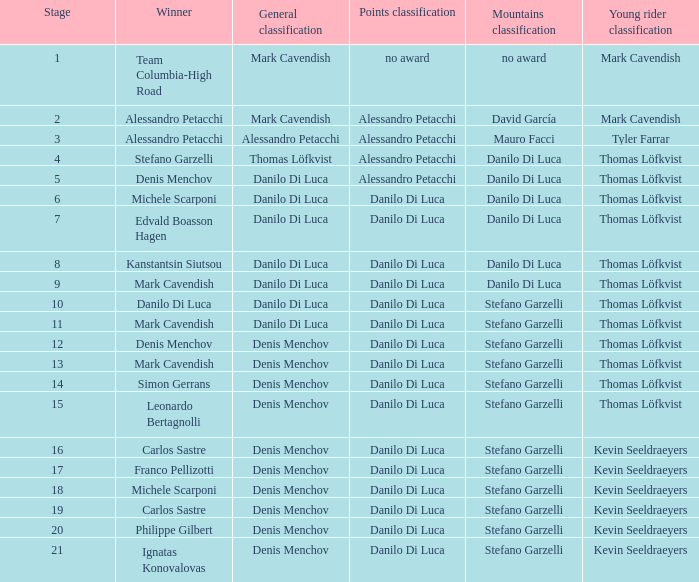When thomas löfkvist is the  young rider classification and alessandro petacchi is the points classification who are the general classifications?  Thomas Löfkvist, Danilo Di Luca. 